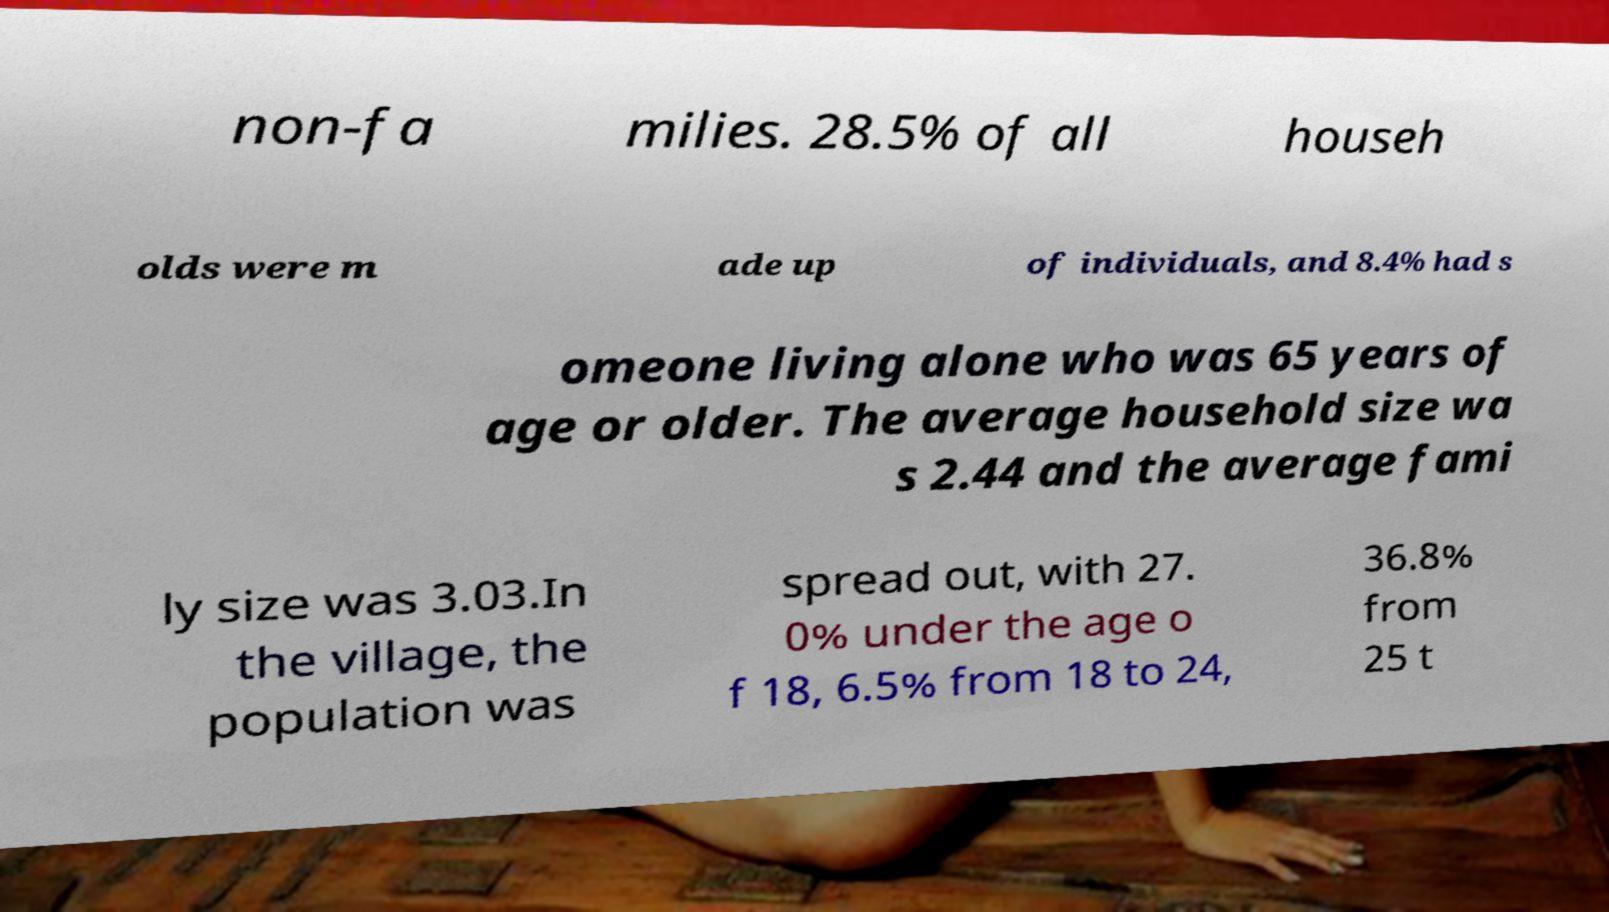I need the written content from this picture converted into text. Can you do that? non-fa milies. 28.5% of all househ olds were m ade up of individuals, and 8.4% had s omeone living alone who was 65 years of age or older. The average household size wa s 2.44 and the average fami ly size was 3.03.In the village, the population was spread out, with 27. 0% under the age o f 18, 6.5% from 18 to 24, 36.8% from 25 t 